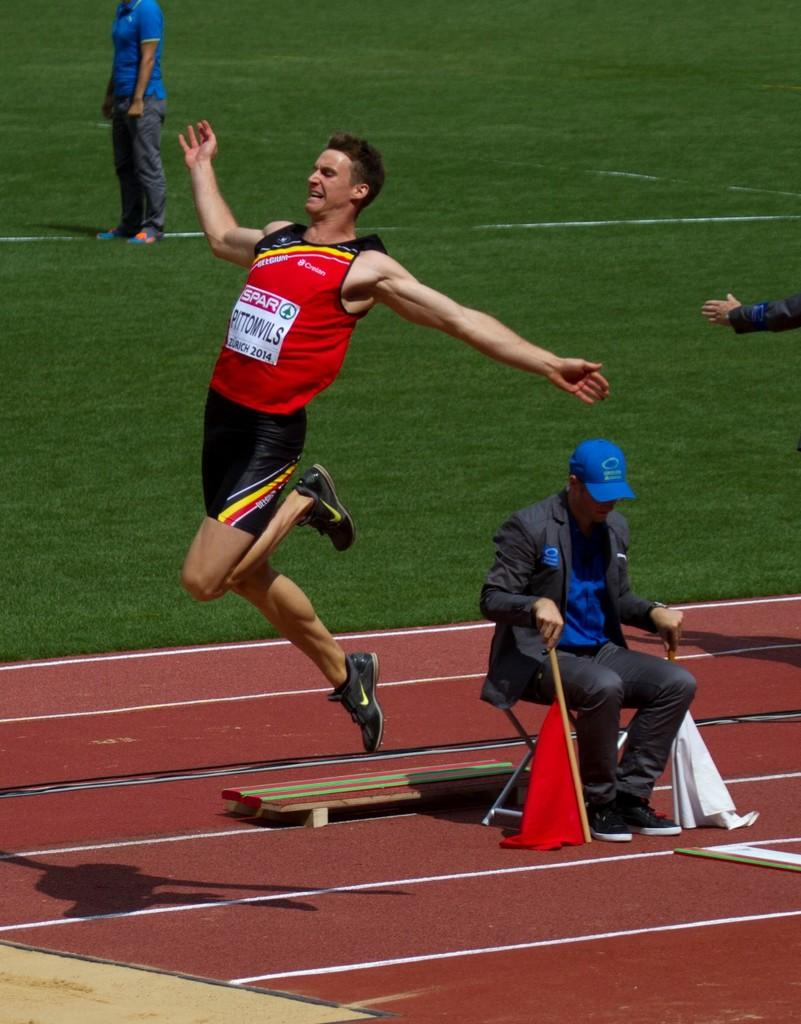What is the man in the image doing? There is a man jumping in the image. Where is the other man located in the image? There is a man sitting at the right side of the image. What is the surface on which the two people are standing? The two people are standing on the grass in the image. What type of arm is visible in the image? There is no arm mentioned or visible in the image. How many bananas are being traded in the image? There are no bananas or any indication of trading in the image. 